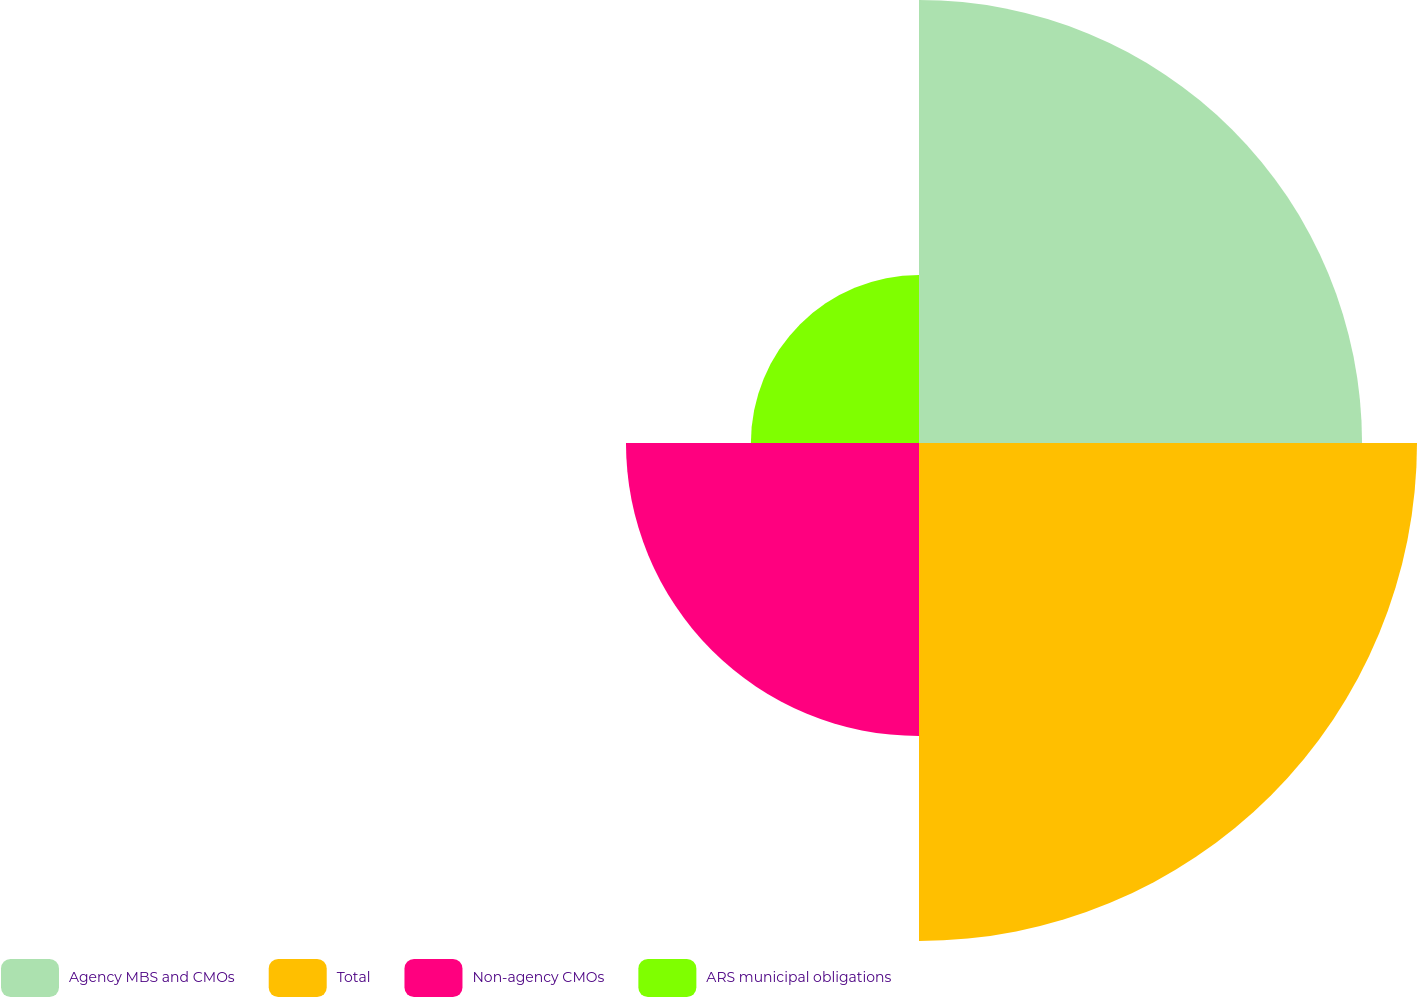Convert chart to OTSL. <chart><loc_0><loc_0><loc_500><loc_500><pie_chart><fcel>Agency MBS and CMOs<fcel>Total<fcel>Non-agency CMOs<fcel>ARS municipal obligations<nl><fcel>31.6%<fcel>35.52%<fcel>20.9%<fcel>11.99%<nl></chart> 